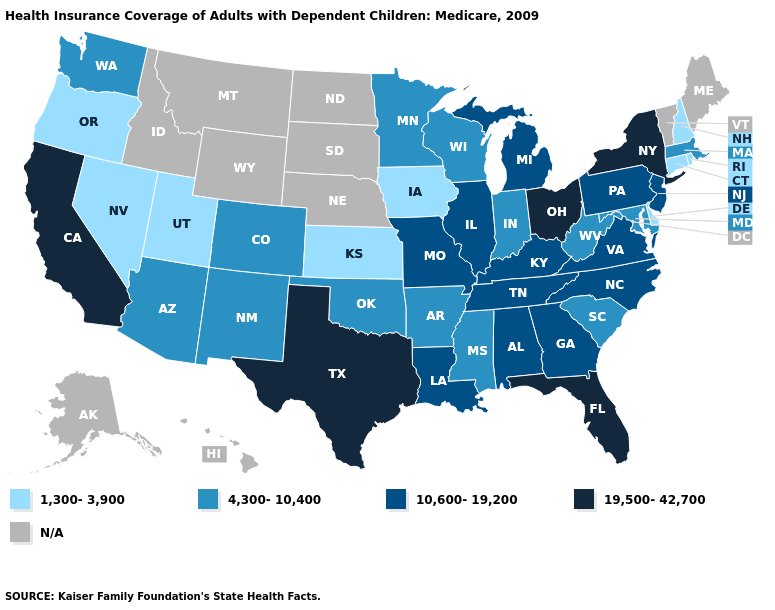What is the value of Florida?
Write a very short answer. 19,500-42,700. Name the states that have a value in the range 1,300-3,900?
Quick response, please. Connecticut, Delaware, Iowa, Kansas, Nevada, New Hampshire, Oregon, Rhode Island, Utah. What is the value of Michigan?
Write a very short answer. 10,600-19,200. Among the states that border Tennessee , does Arkansas have the lowest value?
Be succinct. Yes. Name the states that have a value in the range 1,300-3,900?
Quick response, please. Connecticut, Delaware, Iowa, Kansas, Nevada, New Hampshire, Oregon, Rhode Island, Utah. What is the value of Alabama?
Be succinct. 10,600-19,200. What is the value of South Carolina?
Be succinct. 4,300-10,400. What is the value of Rhode Island?
Keep it brief. 1,300-3,900. What is the value of Connecticut?
Concise answer only. 1,300-3,900. Does the map have missing data?
Answer briefly. Yes. What is the value of West Virginia?
Quick response, please. 4,300-10,400. Name the states that have a value in the range 1,300-3,900?
Concise answer only. Connecticut, Delaware, Iowa, Kansas, Nevada, New Hampshire, Oregon, Rhode Island, Utah. What is the value of Virginia?
Quick response, please. 10,600-19,200. Among the states that border West Virginia , which have the highest value?
Give a very brief answer. Ohio. 